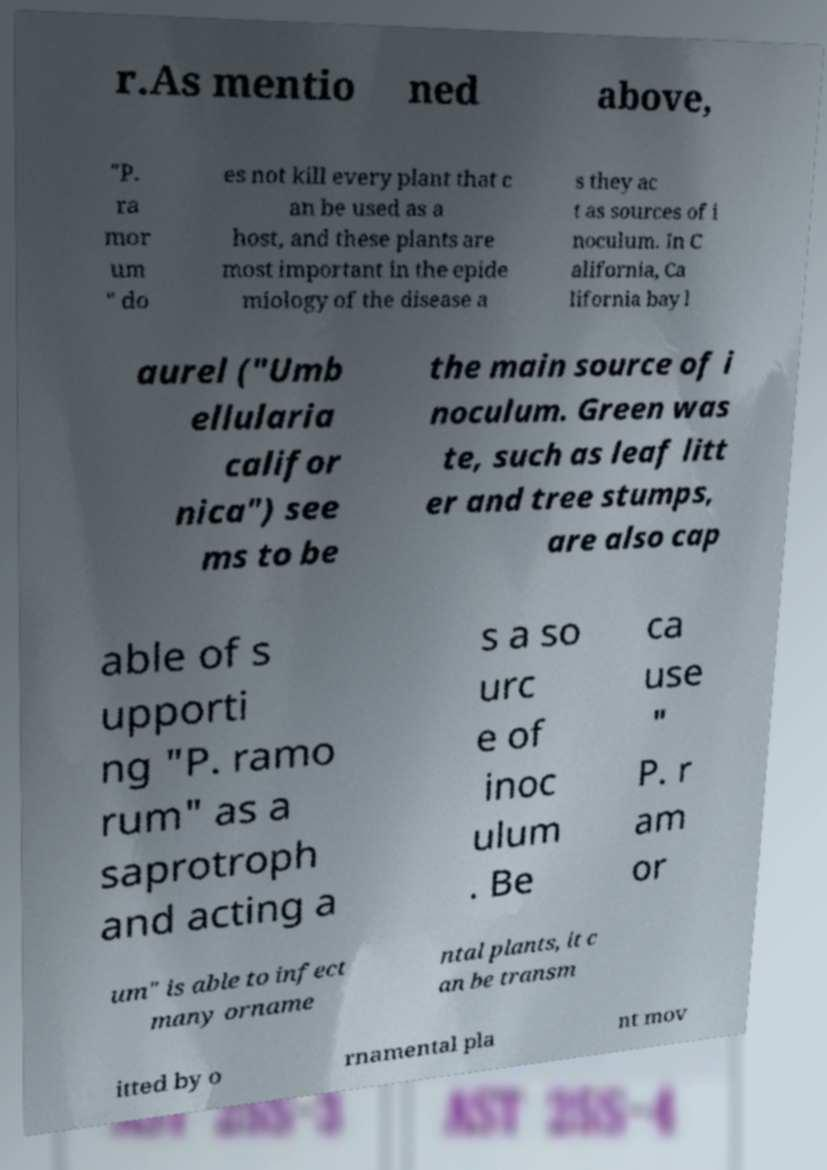Please identify and transcribe the text found in this image. r.As mentio ned above, "P. ra mor um " do es not kill every plant that c an be used as a host, and these plants are most important in the epide miology of the disease a s they ac t as sources of i noculum. In C alifornia, Ca lifornia bay l aurel ("Umb ellularia califor nica") see ms to be the main source of i noculum. Green was te, such as leaf litt er and tree stumps, are also cap able of s upporti ng "P. ramo rum" as a saprotroph and acting a s a so urc e of inoc ulum . Be ca use " P. r am or um" is able to infect many orname ntal plants, it c an be transm itted by o rnamental pla nt mov 